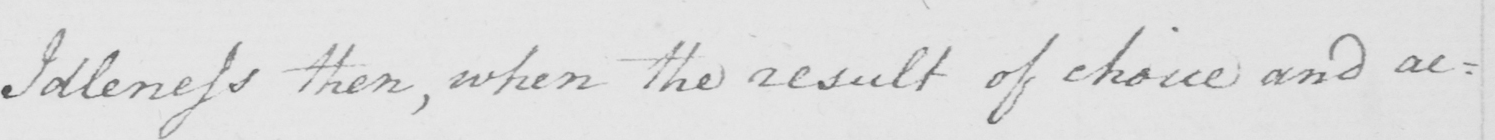Can you tell me what this handwritten text says? Idleness then , when the result of choice and ac : 